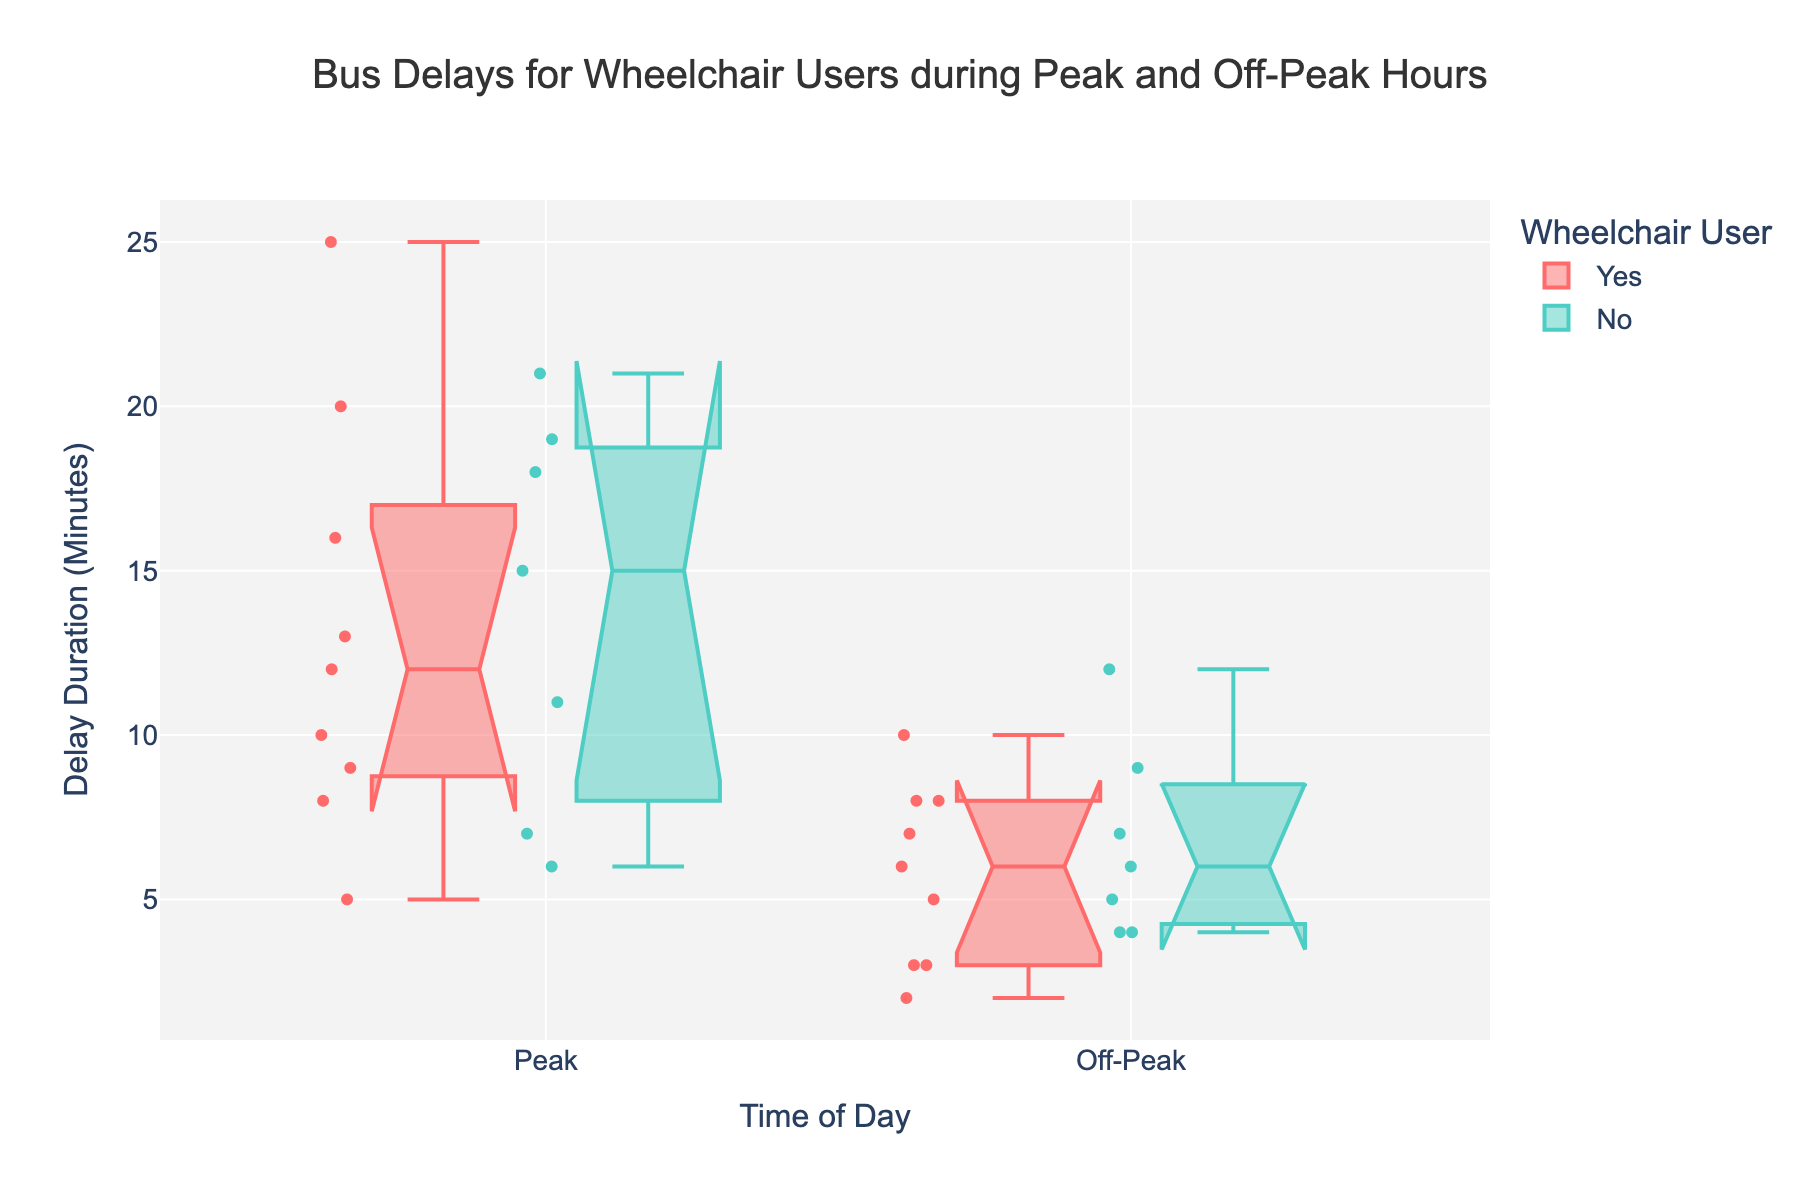How does the median delay duration for wheelchair users during peak hours compare to off-peak hours? By observing the median lines within the notched boxes, we see that the median delay duration for wheelchair users during peak hours is higher than during off-peak hours.
Answer: Higher Is there a significant overlap between the delay durations for wheelchair and non-wheelchair users during off-peak hours? The notched parts of the boxes represent an interval around the median. If the notches of two boxes do not overlap, their medians are significantly different. The notches for off-peak hours overlap for wheelchair and non-wheelchair users, suggesting no significant difference between their medians.
Answer: Yes What is the range of delay durations for wheelchair users during peak hours? The range is determined by the distance between the minimum and maximum values represented by the whiskers. For wheelchair users during peak hours, the range extends from the lowest observed value (5 minutes) to the highest (25 minutes).
Answer: 5 to 25 minutes Are there more outliers during peak hours or off-peak hours for non-wheelchair users? Outliers are depicted as individual points outside the whiskers. By counting these points, it is evident that there are more outliers for non-wheelchair users during peak hours compared to off-peak hours.
Answer: Peak hours Which group has the widest interquartile range (IQR) during peak hours? The IQR is represented by the height of the box. For peak hours, the wheelchair users' box is taller than the non-wheelchair users' box, indicating a wider IQR.
Answer: Wheelchair users What is the upper quartile (75th percentile) delay duration for wheelchair users during off-peak hours? The upper edge of the box represents the 75th percentile. For wheelchair users during off-peak hours, this value is around 8 minutes.
Answer: 8 minutes Does either wheelchair users or non-wheelchair users during peak hours have any delay durations less than the entire range of off-peak hours? Comparing the whiskers of both groups, we notice that the minimum delay duration for non-wheelchair users during peak hours is higher than the maximum during off-peak hours, whereas for wheelchair users, it's not the case since 5 minutes during peak is less than the range for off-peak (2-10 minutes).
Answer: Wheelchair users How does the median delay duration for non-wheelchair users differ between peak and off-peak hours? By comparing the medians (notch centers) of the two boxes for non-wheelchair users, the median during peak hours is higher than during off-peak hours.
Answer: Higher Is there any significant difference in the medians of delay durations for wheelchair users during peak and off-peak hours? Since the notches of the boxes for wheelchair users during peak and off-peak hours do not overlap, we can infer that there is a significant difference in the medians.
Answer: Yes What is the maximum delay duration observed for non-wheelchair users in off-peak hours? The maximum delay is indicated by the upper whisker of the box plot for non-wheelchair users during off-peak hours, which is 12 minutes.
Answer: 12 minutes 